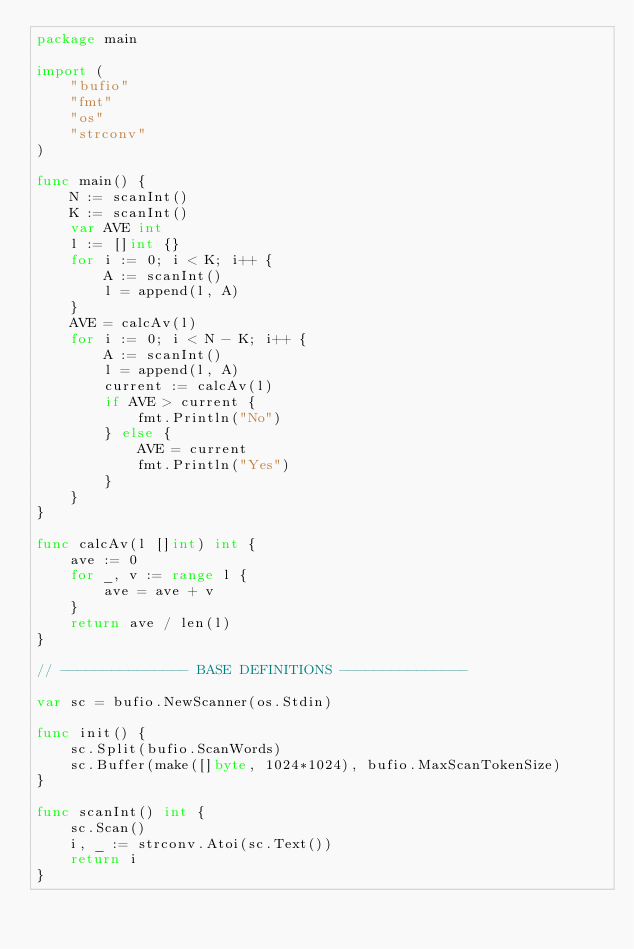<code> <loc_0><loc_0><loc_500><loc_500><_Go_>package main
 
import (
	"bufio"
	"fmt"
	"os"
	"strconv"
)

func main() {
	N := scanInt()
	K := scanInt()
	var AVE int
	l := []int {}
	for i := 0; i < K; i++ {
		A := scanInt()
		l = append(l, A)
	}
	AVE = calcAv(l)
	for i := 0; i < N - K; i++ {
		A := scanInt()
		l = append(l, A)
		current := calcAv(l)
		if AVE > current {
			fmt.Println("No")
		} else {
			AVE = current
			fmt.Println("Yes")
		}
	}
}

func calcAv(l []int) int {
	ave := 0
	for _, v := range l {
		ave = ave + v
	}
	return ave / len(l)
}

// --------------- BASE DEFINITIONS ---------------

var sc = bufio.NewScanner(os.Stdin)
 
func init() {
	sc.Split(bufio.ScanWords)
	sc.Buffer(make([]byte, 1024*1024), bufio.MaxScanTokenSize)
}

func scanInt() int {
	sc.Scan()
	i, _ := strconv.Atoi(sc.Text())
	return i
}
</code> 